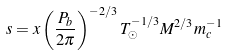Convert formula to latex. <formula><loc_0><loc_0><loc_500><loc_500>s = x \left ( \frac { P _ { b } } { 2 \pi } \right ) ^ { - 2 / 3 } T _ { \odot } ^ { - 1 / 3 } M ^ { 2 / 3 } m _ { c } ^ { - 1 }</formula> 